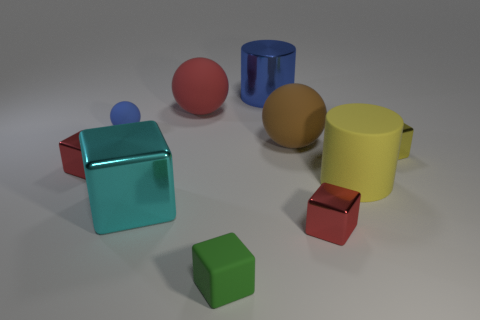Subtract all large red matte balls. How many balls are left? 2 Subtract all green cylinders. How many red blocks are left? 2 Subtract all cyan blocks. How many blocks are left? 4 Subtract 2 cubes. How many cubes are left? 3 Subtract all purple spheres. Subtract all yellow cubes. How many spheres are left? 3 Subtract all spheres. How many objects are left? 7 Add 7 yellow cubes. How many yellow cubes are left? 8 Add 5 cyan objects. How many cyan objects exist? 6 Subtract 0 brown cylinders. How many objects are left? 10 Subtract all tiny green rubber blocks. Subtract all small yellow blocks. How many objects are left? 8 